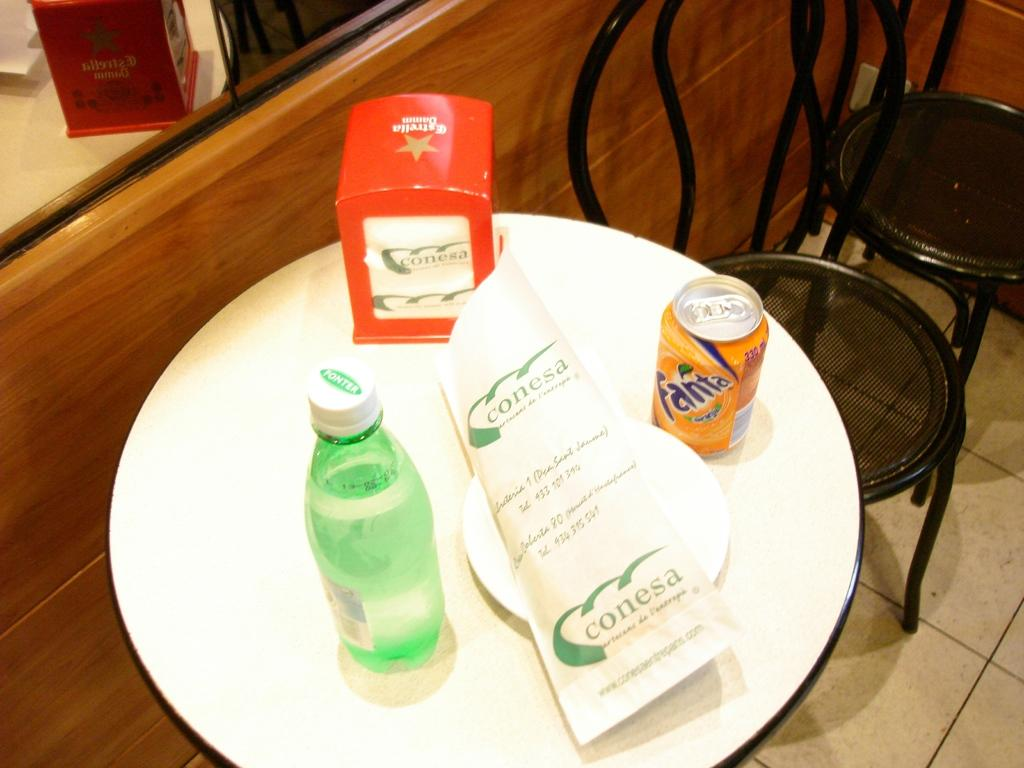What is located in the middle of the image? There is a table in the middle of the image. What objects are on the table? There is a plate, a tin, a box, and a bottle on the table. How many chairs are visible in the image? There are two chairs on the right side of the image. What can be seen in the background of the image? There is a mirror in the background of the image. Can you describe the girl sitting in the van in the image? There is no girl or van present in the image. 